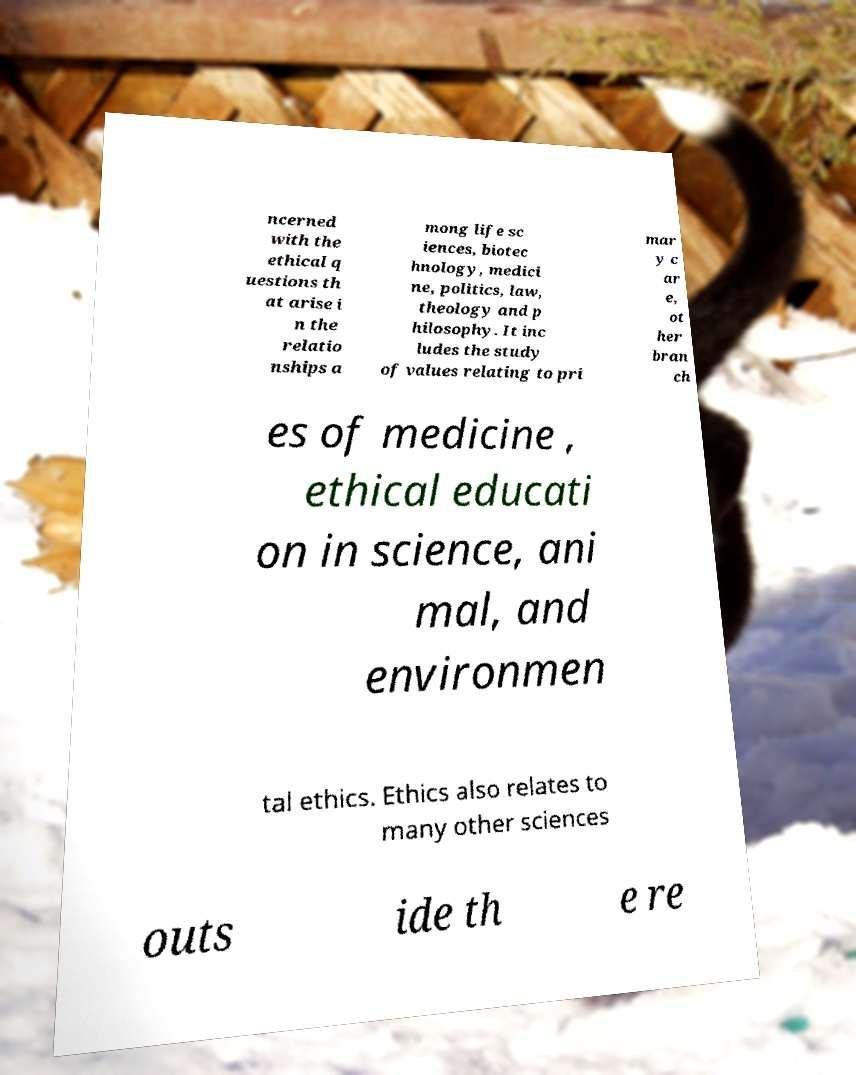I need the written content from this picture converted into text. Can you do that? ncerned with the ethical q uestions th at arise i n the relatio nships a mong life sc iences, biotec hnology, medici ne, politics, law, theology and p hilosophy. It inc ludes the study of values relating to pri mar y c ar e, ot her bran ch es of medicine , ethical educati on in science, ani mal, and environmen tal ethics. Ethics also relates to many other sciences outs ide th e re 